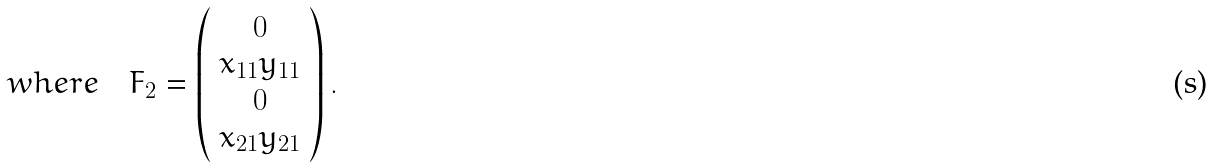<formula> <loc_0><loc_0><loc_500><loc_500>w h e r e \quad F _ { 2 } = \left ( \begin{array} { c } 0 \\ x _ { 1 1 } y _ { 1 1 } \\ 0 \\ x _ { 2 1 } y _ { 2 1 } \end{array} \right ) .</formula> 